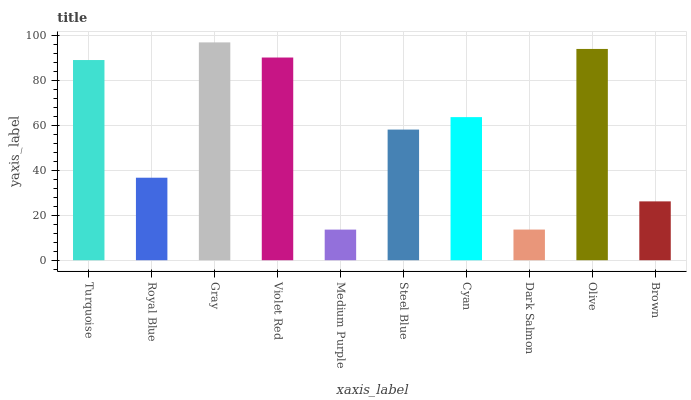Is Medium Purple the minimum?
Answer yes or no. Yes. Is Gray the maximum?
Answer yes or no. Yes. Is Royal Blue the minimum?
Answer yes or no. No. Is Royal Blue the maximum?
Answer yes or no. No. Is Turquoise greater than Royal Blue?
Answer yes or no. Yes. Is Royal Blue less than Turquoise?
Answer yes or no. Yes. Is Royal Blue greater than Turquoise?
Answer yes or no. No. Is Turquoise less than Royal Blue?
Answer yes or no. No. Is Cyan the high median?
Answer yes or no. Yes. Is Steel Blue the low median?
Answer yes or no. Yes. Is Turquoise the high median?
Answer yes or no. No. Is Violet Red the low median?
Answer yes or no. No. 